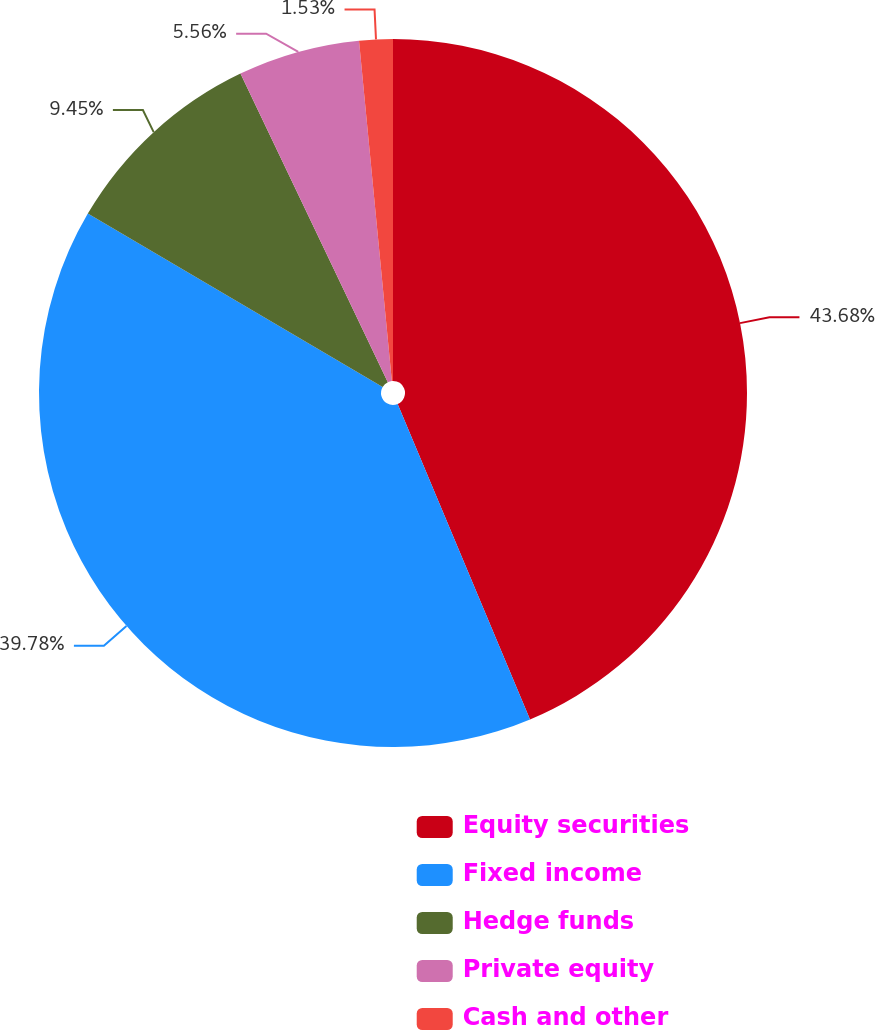<chart> <loc_0><loc_0><loc_500><loc_500><pie_chart><fcel>Equity securities<fcel>Fixed income<fcel>Hedge funds<fcel>Private equity<fcel>Cash and other<nl><fcel>43.67%<fcel>39.78%<fcel>9.45%<fcel>5.56%<fcel>1.53%<nl></chart> 